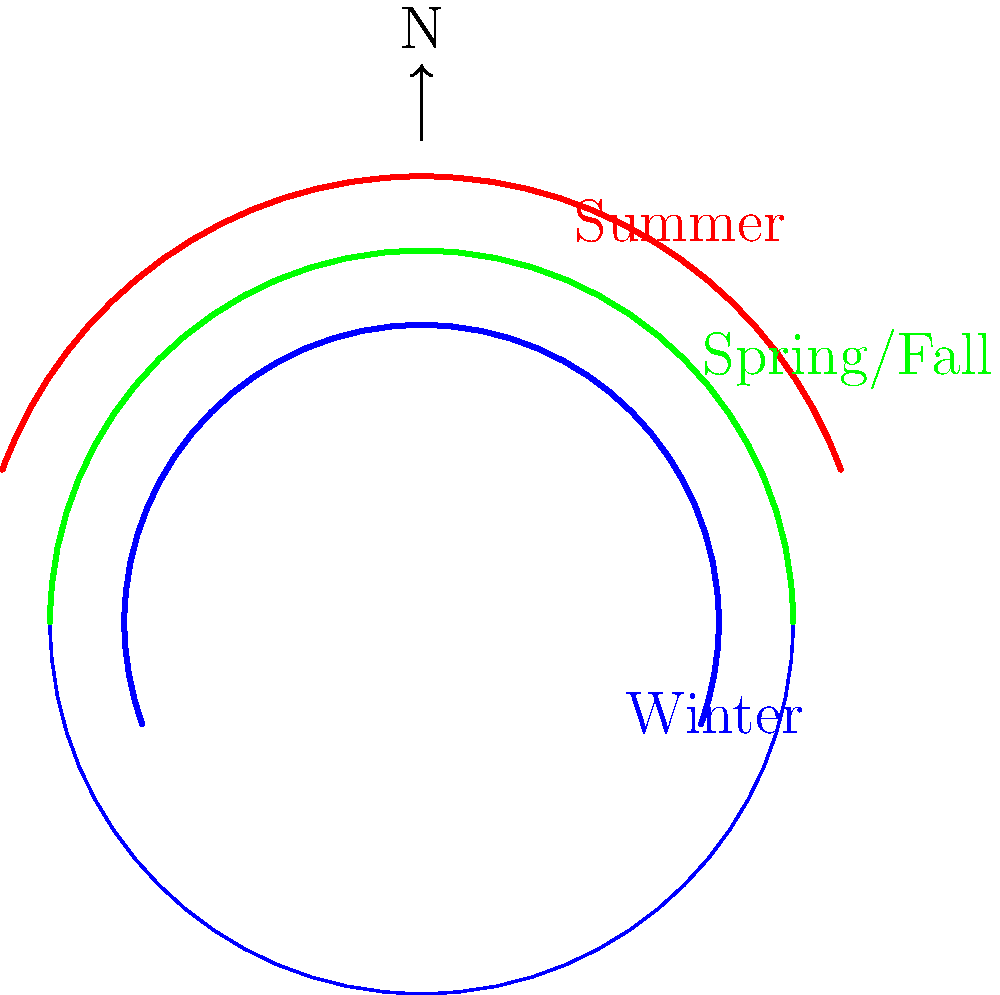In track and field, understanding the Sun's position can be crucial for scheduling outdoor events. The diagram shows the apparent path of the Sun across the sky at different times of the year. What causes the variation in the Sun's path, and how does this affect the length of daylight hours? To understand the variation in the Sun's path and its effect on daylight hours, let's break it down step-by-step:

1. Earth's axial tilt: The Earth's axis is tilted at an angle of approximately 23.5° relative to its orbital plane around the Sun.

2. Orbital motion: As the Earth orbits the Sun, this tilt causes different parts of the Earth to be angled towards or away from the Sun at different times of the year.

3. Seasonal variations:
   a. Summer: The hemisphere tilted towards the Sun experiences summer. The Sun's path is higher in the sky (red arc in the diagram).
   b. Winter: The hemisphere tilted away from the Sun experiences winter. The Sun's path is lower in the sky (blue arc in the diagram).
   c. Spring/Fall: During the equinoxes, the Sun's path is between the summer and winter extremes (green arc in the diagram).

4. Effect on daylight hours:
   a. Summer: Higher path means the Sun is above the horizon for a longer time, resulting in longer days.
   b. Winter: Lower path means the Sun is above the horizon for a shorter time, resulting in shorter days.
   c. Spring/Fall: Intermediate path results in roughly equal day and night lengths.

5. Latitude effect: The variation in daylight hours is more pronounced at higher latitudes and less noticeable near the equator.

This understanding is important for track and field scheduling because:
- Longer summer days allow for extended practice times and later event scheduling.
- Shorter winter days may require adjusting practice schedules or using artificial lighting.
- The Sun's position affects shadows and glare, which can impact athlete performance and viewer experience.
Answer: Earth's axial tilt causes seasonal variation in the Sun's path, affecting daylight hours (longer in summer, shorter in winter). 